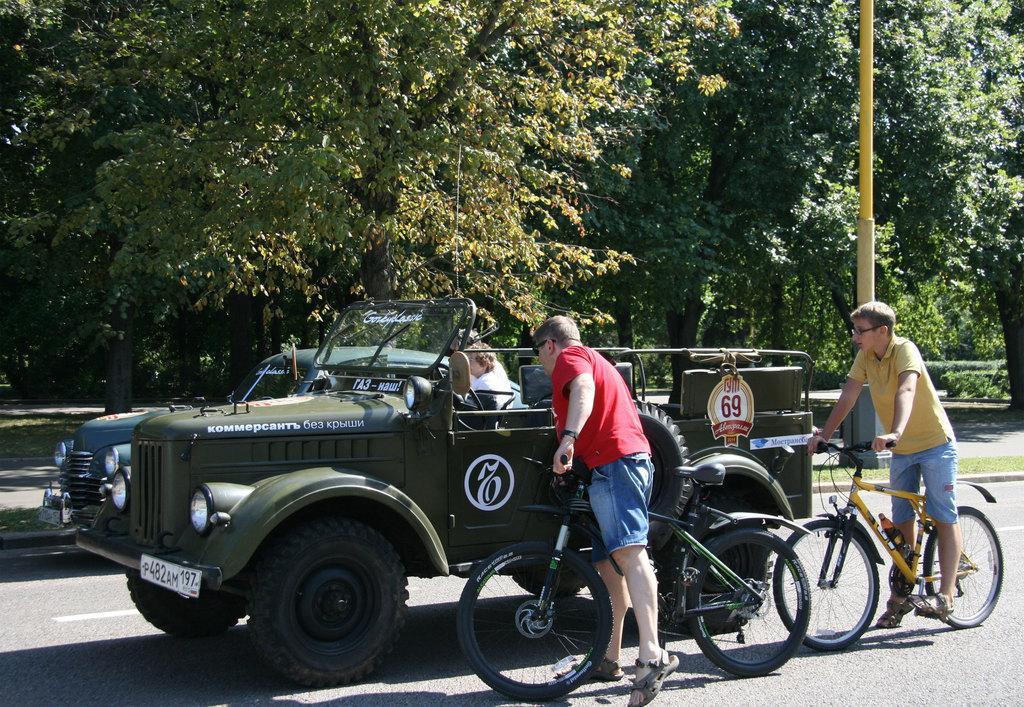Can you describe this image briefly? Here we can see a jeep, a car and two persons who are on the bicycle. This is a tree and this is a pole. 